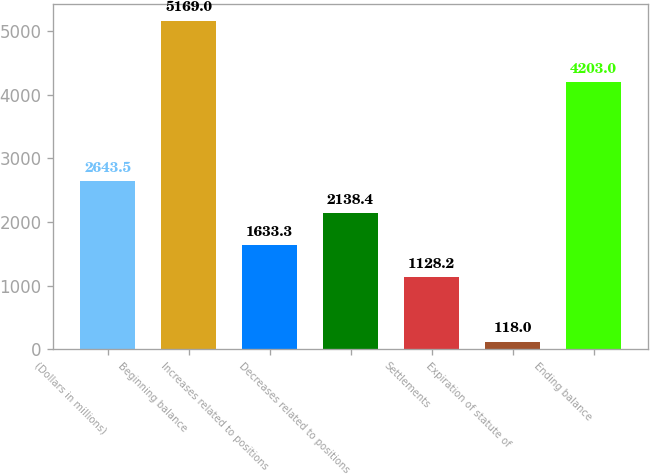Convert chart to OTSL. <chart><loc_0><loc_0><loc_500><loc_500><bar_chart><fcel>(Dollars in millions)<fcel>Beginning balance<fcel>Increases related to positions<fcel>Decreases related to positions<fcel>Settlements<fcel>Expiration of statute of<fcel>Ending balance<nl><fcel>2643.5<fcel>5169<fcel>1633.3<fcel>2138.4<fcel>1128.2<fcel>118<fcel>4203<nl></chart> 